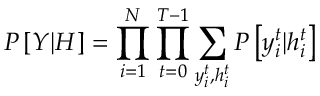<formula> <loc_0><loc_0><loc_500><loc_500>P \left [ Y | H \right ] = \prod _ { i = 1 } ^ { N } \prod _ { t = 0 } ^ { T - 1 } \sum _ { y _ { i } ^ { t } , h _ { i } ^ { t } } P \left [ y _ { i } ^ { t } | h _ { i } ^ { t } \right ]</formula> 